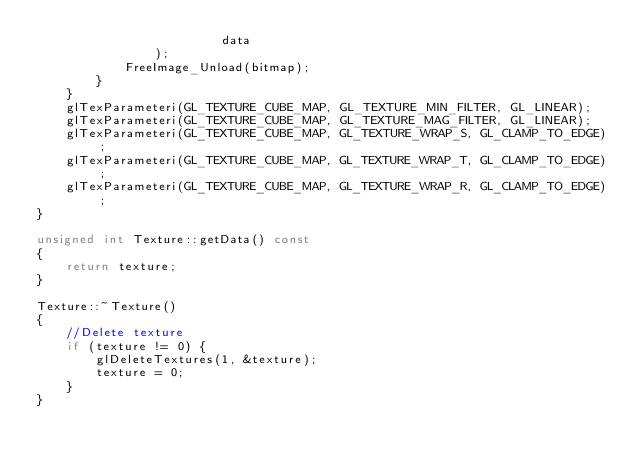<code> <loc_0><loc_0><loc_500><loc_500><_C++_>                         data
                );
            FreeImage_Unload(bitmap);
        }
    }
    glTexParameteri(GL_TEXTURE_CUBE_MAP, GL_TEXTURE_MIN_FILTER, GL_LINEAR);
    glTexParameteri(GL_TEXTURE_CUBE_MAP, GL_TEXTURE_MAG_FILTER, GL_LINEAR);
    glTexParameteri(GL_TEXTURE_CUBE_MAP, GL_TEXTURE_WRAP_S, GL_CLAMP_TO_EDGE);
    glTexParameteri(GL_TEXTURE_CUBE_MAP, GL_TEXTURE_WRAP_T, GL_CLAMP_TO_EDGE);
    glTexParameteri(GL_TEXTURE_CUBE_MAP, GL_TEXTURE_WRAP_R, GL_CLAMP_TO_EDGE);
}

unsigned int Texture::getData() const
{
    return texture;
}

Texture::~Texture()
{
    //Delete texture
    if (texture != 0) {
        glDeleteTextures(1, &texture);
        texture = 0;
    }
}
</code> 